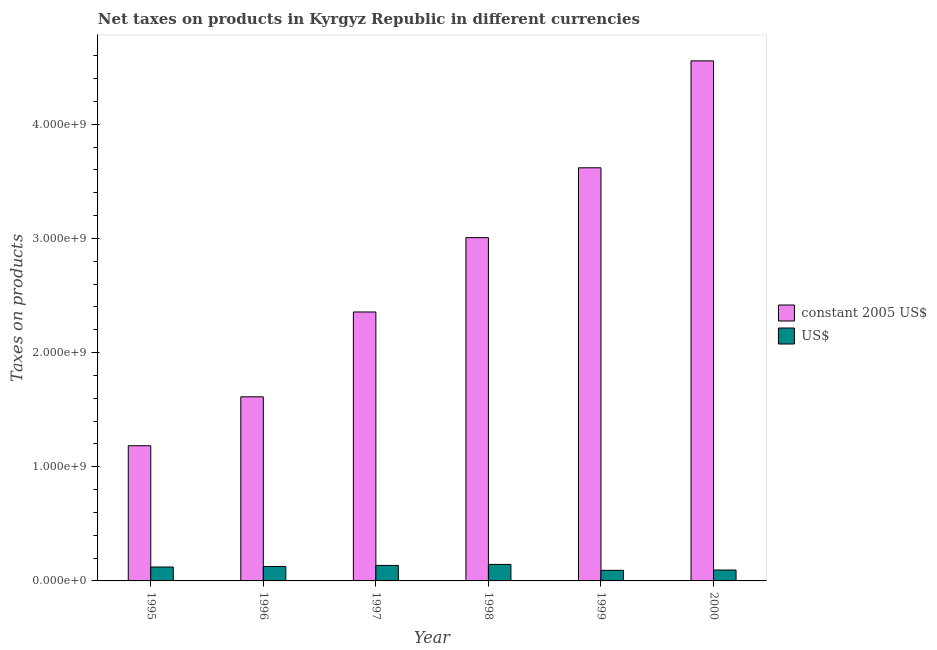How many groups of bars are there?
Your answer should be compact. 6. Are the number of bars per tick equal to the number of legend labels?
Offer a terse response. Yes. How many bars are there on the 2nd tick from the left?
Ensure brevity in your answer.  2. How many bars are there on the 1st tick from the right?
Make the answer very short. 2. What is the label of the 5th group of bars from the left?
Offer a terse response. 1999. What is the net taxes in constant 2005 us$ in 1998?
Offer a terse response. 3.01e+09. Across all years, what is the maximum net taxes in constant 2005 us$?
Your answer should be compact. 4.56e+09. Across all years, what is the minimum net taxes in us$?
Make the answer very short. 9.27e+07. In which year was the net taxes in us$ maximum?
Your answer should be very brief. 1998. In which year was the net taxes in constant 2005 us$ minimum?
Provide a succinct answer. 1995. What is the total net taxes in us$ in the graph?
Offer a terse response. 7.17e+08. What is the difference between the net taxes in us$ in 1996 and that in 1997?
Give a very brief answer. -9.76e+06. What is the difference between the net taxes in constant 2005 us$ in 1996 and the net taxes in us$ in 2000?
Your response must be concise. -2.94e+09. What is the average net taxes in constant 2005 us$ per year?
Your answer should be very brief. 2.72e+09. In the year 1999, what is the difference between the net taxes in constant 2005 us$ and net taxes in us$?
Provide a short and direct response. 0. What is the ratio of the net taxes in us$ in 1995 to that in 1996?
Offer a very short reply. 0.97. What is the difference between the highest and the second highest net taxes in constant 2005 us$?
Offer a very short reply. 9.37e+08. What is the difference between the highest and the lowest net taxes in constant 2005 us$?
Your answer should be compact. 3.37e+09. Is the sum of the net taxes in us$ in 1995 and 1996 greater than the maximum net taxes in constant 2005 us$ across all years?
Offer a very short reply. Yes. What does the 2nd bar from the left in 1997 represents?
Provide a succinct answer. US$. What does the 2nd bar from the right in 1999 represents?
Give a very brief answer. Constant 2005 us$. Are all the bars in the graph horizontal?
Your answer should be compact. No. What is the difference between two consecutive major ticks on the Y-axis?
Make the answer very short. 1.00e+09. Are the values on the major ticks of Y-axis written in scientific E-notation?
Offer a very short reply. Yes. Does the graph contain any zero values?
Your response must be concise. No. Does the graph contain grids?
Your answer should be compact. No. Where does the legend appear in the graph?
Give a very brief answer. Center right. How many legend labels are there?
Offer a very short reply. 2. What is the title of the graph?
Offer a very short reply. Net taxes on products in Kyrgyz Republic in different currencies. Does "Foreign Liabilities" appear as one of the legend labels in the graph?
Make the answer very short. No. What is the label or title of the Y-axis?
Your response must be concise. Taxes on products. What is the Taxes on products in constant 2005 US$ in 1995?
Keep it short and to the point. 1.18e+09. What is the Taxes on products in US$ in 1995?
Make the answer very short. 1.22e+08. What is the Taxes on products of constant 2005 US$ in 1996?
Ensure brevity in your answer.  1.61e+09. What is the Taxes on products of US$ in 1996?
Make the answer very short. 1.26e+08. What is the Taxes on products of constant 2005 US$ in 1997?
Provide a succinct answer. 2.36e+09. What is the Taxes on products in US$ in 1997?
Keep it short and to the point. 1.36e+08. What is the Taxes on products of constant 2005 US$ in 1998?
Offer a terse response. 3.01e+09. What is the Taxes on products in US$ in 1998?
Give a very brief answer. 1.45e+08. What is the Taxes on products of constant 2005 US$ in 1999?
Provide a short and direct response. 3.62e+09. What is the Taxes on products in US$ in 1999?
Make the answer very short. 9.27e+07. What is the Taxes on products of constant 2005 US$ in 2000?
Offer a terse response. 4.56e+09. What is the Taxes on products of US$ in 2000?
Keep it short and to the point. 9.55e+07. Across all years, what is the maximum Taxes on products of constant 2005 US$?
Offer a terse response. 4.56e+09. Across all years, what is the maximum Taxes on products in US$?
Offer a terse response. 1.45e+08. Across all years, what is the minimum Taxes on products in constant 2005 US$?
Ensure brevity in your answer.  1.18e+09. Across all years, what is the minimum Taxes on products of US$?
Ensure brevity in your answer.  9.27e+07. What is the total Taxes on products in constant 2005 US$ in the graph?
Provide a short and direct response. 1.63e+1. What is the total Taxes on products in US$ in the graph?
Keep it short and to the point. 7.17e+08. What is the difference between the Taxes on products of constant 2005 US$ in 1995 and that in 1996?
Your answer should be compact. -4.28e+08. What is the difference between the Taxes on products in US$ in 1995 and that in 1996?
Offer a terse response. -4.12e+06. What is the difference between the Taxes on products in constant 2005 US$ in 1995 and that in 1997?
Give a very brief answer. -1.17e+09. What is the difference between the Taxes on products of US$ in 1995 and that in 1997?
Offer a very short reply. -1.39e+07. What is the difference between the Taxes on products of constant 2005 US$ in 1995 and that in 1998?
Provide a succinct answer. -1.82e+09. What is the difference between the Taxes on products in US$ in 1995 and that in 1998?
Offer a terse response. -2.30e+07. What is the difference between the Taxes on products in constant 2005 US$ in 1995 and that in 1999?
Provide a succinct answer. -2.43e+09. What is the difference between the Taxes on products in US$ in 1995 and that in 1999?
Make the answer very short. 2.91e+07. What is the difference between the Taxes on products of constant 2005 US$ in 1995 and that in 2000?
Your response must be concise. -3.37e+09. What is the difference between the Taxes on products in US$ in 1995 and that in 2000?
Give a very brief answer. 2.64e+07. What is the difference between the Taxes on products in constant 2005 US$ in 1996 and that in 1997?
Offer a very short reply. -7.43e+08. What is the difference between the Taxes on products in US$ in 1996 and that in 1997?
Make the answer very short. -9.76e+06. What is the difference between the Taxes on products of constant 2005 US$ in 1996 and that in 1998?
Ensure brevity in your answer.  -1.39e+09. What is the difference between the Taxes on products in US$ in 1996 and that in 1998?
Offer a very short reply. -1.88e+07. What is the difference between the Taxes on products in constant 2005 US$ in 1996 and that in 1999?
Make the answer very short. -2.01e+09. What is the difference between the Taxes on products of US$ in 1996 and that in 1999?
Offer a terse response. 3.32e+07. What is the difference between the Taxes on products in constant 2005 US$ in 1996 and that in 2000?
Provide a succinct answer. -2.94e+09. What is the difference between the Taxes on products in US$ in 1996 and that in 2000?
Your answer should be very brief. 3.05e+07. What is the difference between the Taxes on products of constant 2005 US$ in 1997 and that in 1998?
Ensure brevity in your answer.  -6.51e+08. What is the difference between the Taxes on products of US$ in 1997 and that in 1998?
Your answer should be compact. -9.08e+06. What is the difference between the Taxes on products of constant 2005 US$ in 1997 and that in 1999?
Give a very brief answer. -1.26e+09. What is the difference between the Taxes on products in US$ in 1997 and that in 1999?
Keep it short and to the point. 4.30e+07. What is the difference between the Taxes on products in constant 2005 US$ in 1997 and that in 2000?
Your answer should be compact. -2.20e+09. What is the difference between the Taxes on products of US$ in 1997 and that in 2000?
Keep it short and to the point. 4.03e+07. What is the difference between the Taxes on products in constant 2005 US$ in 1998 and that in 1999?
Provide a short and direct response. -6.12e+08. What is the difference between the Taxes on products of US$ in 1998 and that in 1999?
Provide a short and direct response. 5.21e+07. What is the difference between the Taxes on products in constant 2005 US$ in 1998 and that in 2000?
Offer a terse response. -1.55e+09. What is the difference between the Taxes on products in US$ in 1998 and that in 2000?
Provide a succinct answer. 4.93e+07. What is the difference between the Taxes on products in constant 2005 US$ in 1999 and that in 2000?
Your answer should be very brief. -9.37e+08. What is the difference between the Taxes on products of US$ in 1999 and that in 2000?
Provide a succinct answer. -2.74e+06. What is the difference between the Taxes on products of constant 2005 US$ in 1995 and the Taxes on products of US$ in 1996?
Make the answer very short. 1.06e+09. What is the difference between the Taxes on products of constant 2005 US$ in 1995 and the Taxes on products of US$ in 1997?
Provide a short and direct response. 1.05e+09. What is the difference between the Taxes on products of constant 2005 US$ in 1995 and the Taxes on products of US$ in 1998?
Make the answer very short. 1.04e+09. What is the difference between the Taxes on products of constant 2005 US$ in 1995 and the Taxes on products of US$ in 1999?
Your answer should be very brief. 1.09e+09. What is the difference between the Taxes on products of constant 2005 US$ in 1995 and the Taxes on products of US$ in 2000?
Your answer should be compact. 1.09e+09. What is the difference between the Taxes on products in constant 2005 US$ in 1996 and the Taxes on products in US$ in 1997?
Your answer should be compact. 1.48e+09. What is the difference between the Taxes on products in constant 2005 US$ in 1996 and the Taxes on products in US$ in 1998?
Give a very brief answer. 1.47e+09. What is the difference between the Taxes on products of constant 2005 US$ in 1996 and the Taxes on products of US$ in 1999?
Offer a terse response. 1.52e+09. What is the difference between the Taxes on products in constant 2005 US$ in 1996 and the Taxes on products in US$ in 2000?
Make the answer very short. 1.52e+09. What is the difference between the Taxes on products in constant 2005 US$ in 1997 and the Taxes on products in US$ in 1998?
Ensure brevity in your answer.  2.21e+09. What is the difference between the Taxes on products in constant 2005 US$ in 1997 and the Taxes on products in US$ in 1999?
Offer a very short reply. 2.26e+09. What is the difference between the Taxes on products in constant 2005 US$ in 1997 and the Taxes on products in US$ in 2000?
Offer a terse response. 2.26e+09. What is the difference between the Taxes on products of constant 2005 US$ in 1998 and the Taxes on products of US$ in 1999?
Provide a short and direct response. 2.91e+09. What is the difference between the Taxes on products of constant 2005 US$ in 1998 and the Taxes on products of US$ in 2000?
Keep it short and to the point. 2.91e+09. What is the difference between the Taxes on products in constant 2005 US$ in 1999 and the Taxes on products in US$ in 2000?
Your answer should be compact. 3.52e+09. What is the average Taxes on products of constant 2005 US$ per year?
Keep it short and to the point. 2.72e+09. What is the average Taxes on products in US$ per year?
Your response must be concise. 1.19e+08. In the year 1995, what is the difference between the Taxes on products of constant 2005 US$ and Taxes on products of US$?
Your answer should be very brief. 1.06e+09. In the year 1996, what is the difference between the Taxes on products in constant 2005 US$ and Taxes on products in US$?
Your answer should be compact. 1.49e+09. In the year 1997, what is the difference between the Taxes on products in constant 2005 US$ and Taxes on products in US$?
Provide a short and direct response. 2.22e+09. In the year 1998, what is the difference between the Taxes on products in constant 2005 US$ and Taxes on products in US$?
Your response must be concise. 2.86e+09. In the year 1999, what is the difference between the Taxes on products of constant 2005 US$ and Taxes on products of US$?
Your answer should be very brief. 3.53e+09. In the year 2000, what is the difference between the Taxes on products of constant 2005 US$ and Taxes on products of US$?
Offer a terse response. 4.46e+09. What is the ratio of the Taxes on products of constant 2005 US$ in 1995 to that in 1996?
Offer a very short reply. 0.73. What is the ratio of the Taxes on products of US$ in 1995 to that in 1996?
Provide a short and direct response. 0.97. What is the ratio of the Taxes on products in constant 2005 US$ in 1995 to that in 1997?
Your answer should be very brief. 0.5. What is the ratio of the Taxes on products of US$ in 1995 to that in 1997?
Your response must be concise. 0.9. What is the ratio of the Taxes on products of constant 2005 US$ in 1995 to that in 1998?
Your answer should be compact. 0.39. What is the ratio of the Taxes on products of US$ in 1995 to that in 1998?
Keep it short and to the point. 0.84. What is the ratio of the Taxes on products of constant 2005 US$ in 1995 to that in 1999?
Your answer should be very brief. 0.33. What is the ratio of the Taxes on products in US$ in 1995 to that in 1999?
Provide a succinct answer. 1.31. What is the ratio of the Taxes on products in constant 2005 US$ in 1995 to that in 2000?
Your answer should be compact. 0.26. What is the ratio of the Taxes on products of US$ in 1995 to that in 2000?
Offer a very short reply. 1.28. What is the ratio of the Taxes on products in constant 2005 US$ in 1996 to that in 1997?
Give a very brief answer. 0.68. What is the ratio of the Taxes on products of US$ in 1996 to that in 1997?
Your answer should be compact. 0.93. What is the ratio of the Taxes on products of constant 2005 US$ in 1996 to that in 1998?
Your answer should be very brief. 0.54. What is the ratio of the Taxes on products in US$ in 1996 to that in 1998?
Provide a succinct answer. 0.87. What is the ratio of the Taxes on products of constant 2005 US$ in 1996 to that in 1999?
Give a very brief answer. 0.45. What is the ratio of the Taxes on products of US$ in 1996 to that in 1999?
Your answer should be compact. 1.36. What is the ratio of the Taxes on products of constant 2005 US$ in 1996 to that in 2000?
Provide a short and direct response. 0.35. What is the ratio of the Taxes on products in US$ in 1996 to that in 2000?
Give a very brief answer. 1.32. What is the ratio of the Taxes on products of constant 2005 US$ in 1997 to that in 1998?
Your answer should be compact. 0.78. What is the ratio of the Taxes on products of US$ in 1997 to that in 1998?
Offer a very short reply. 0.94. What is the ratio of the Taxes on products of constant 2005 US$ in 1997 to that in 1999?
Offer a terse response. 0.65. What is the ratio of the Taxes on products in US$ in 1997 to that in 1999?
Give a very brief answer. 1.46. What is the ratio of the Taxes on products of constant 2005 US$ in 1997 to that in 2000?
Offer a terse response. 0.52. What is the ratio of the Taxes on products in US$ in 1997 to that in 2000?
Provide a succinct answer. 1.42. What is the ratio of the Taxes on products in constant 2005 US$ in 1998 to that in 1999?
Your answer should be compact. 0.83. What is the ratio of the Taxes on products of US$ in 1998 to that in 1999?
Give a very brief answer. 1.56. What is the ratio of the Taxes on products in constant 2005 US$ in 1998 to that in 2000?
Your response must be concise. 0.66. What is the ratio of the Taxes on products in US$ in 1998 to that in 2000?
Offer a terse response. 1.52. What is the ratio of the Taxes on products in constant 2005 US$ in 1999 to that in 2000?
Make the answer very short. 0.79. What is the ratio of the Taxes on products of US$ in 1999 to that in 2000?
Offer a very short reply. 0.97. What is the difference between the highest and the second highest Taxes on products in constant 2005 US$?
Your answer should be very brief. 9.37e+08. What is the difference between the highest and the second highest Taxes on products of US$?
Keep it short and to the point. 9.08e+06. What is the difference between the highest and the lowest Taxes on products in constant 2005 US$?
Make the answer very short. 3.37e+09. What is the difference between the highest and the lowest Taxes on products in US$?
Your answer should be very brief. 5.21e+07. 